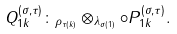Convert formula to latex. <formula><loc_0><loc_0><loc_500><loc_500>Q _ { 1 k } ^ { ( \sigma , \tau ) } \colon _ { \rho _ { \tau ( k ) } } \otimes _ { \lambda _ { \sigma ( 1 ) } } \circ P _ { 1 k } ^ { ( \sigma , \tau ) } .</formula> 